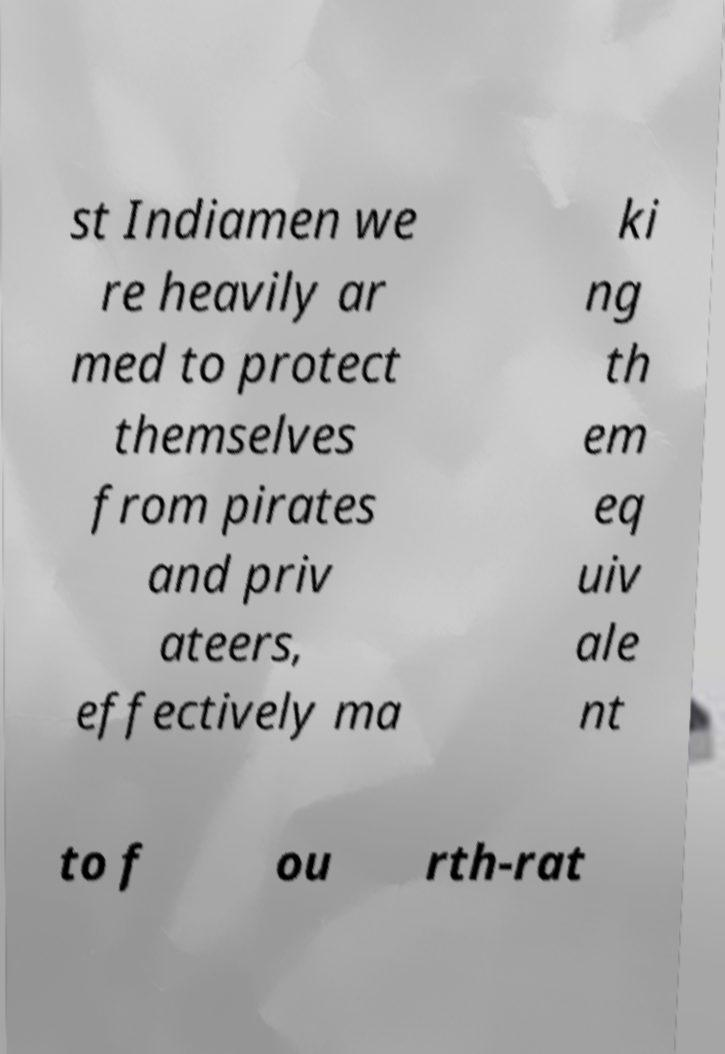Please identify and transcribe the text found in this image. st Indiamen we re heavily ar med to protect themselves from pirates and priv ateers, effectively ma ki ng th em eq uiv ale nt to f ou rth-rat 